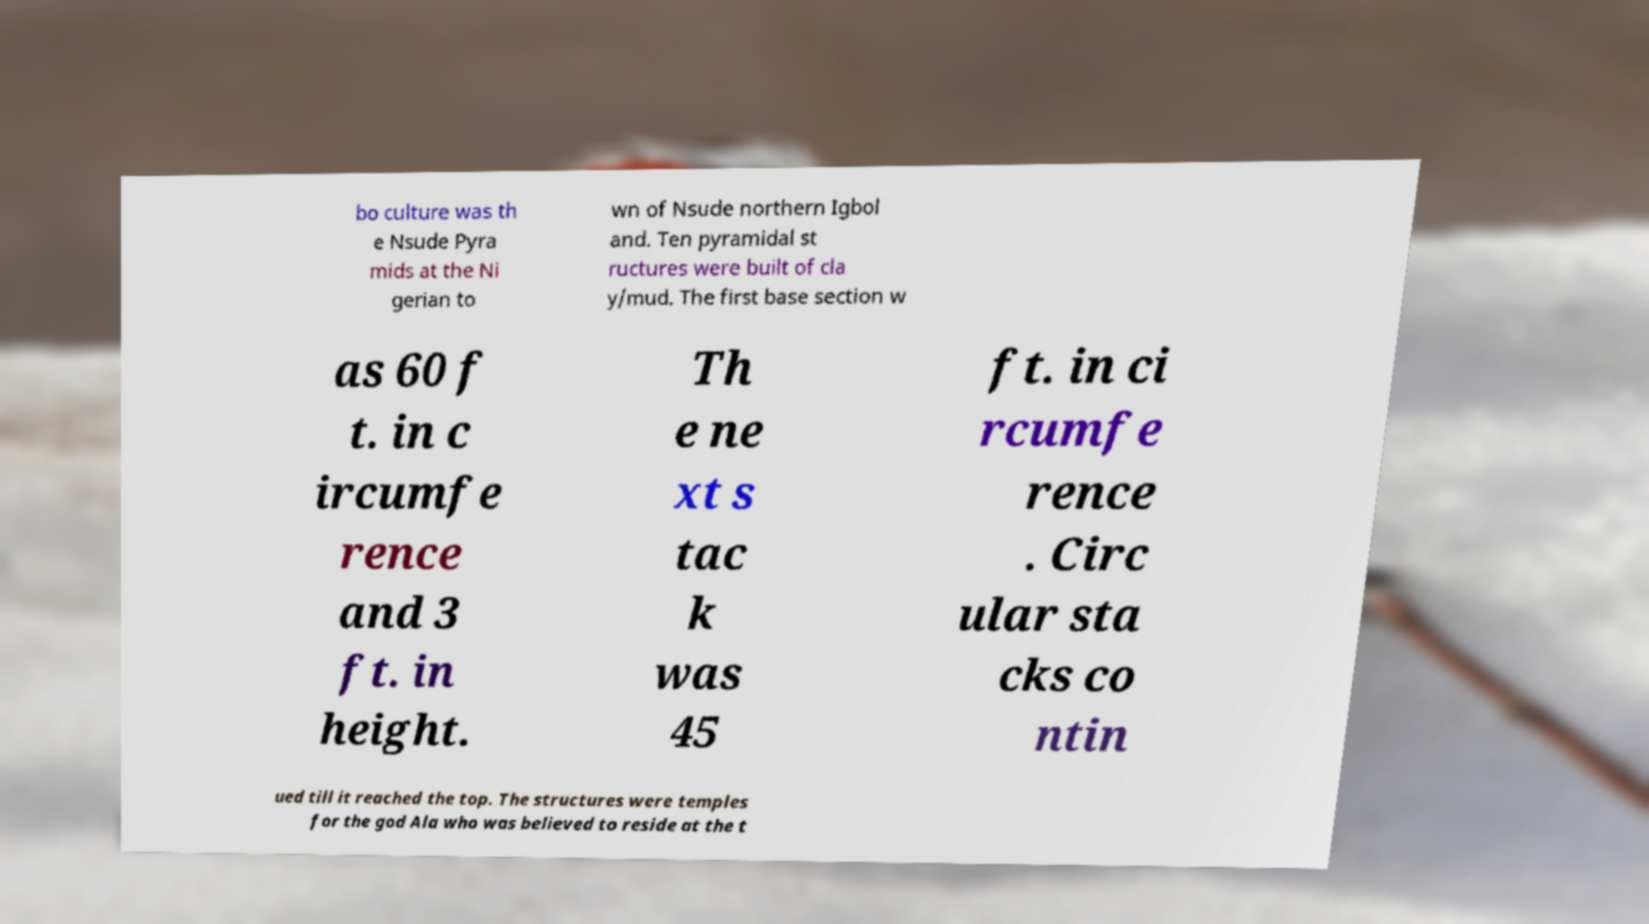There's text embedded in this image that I need extracted. Can you transcribe it verbatim? bo culture was th e Nsude Pyra mids at the Ni gerian to wn of Nsude northern Igbol and. Ten pyramidal st ructures were built of cla y/mud. The first base section w as 60 f t. in c ircumfe rence and 3 ft. in height. Th e ne xt s tac k was 45 ft. in ci rcumfe rence . Circ ular sta cks co ntin ued till it reached the top. The structures were temples for the god Ala who was believed to reside at the t 